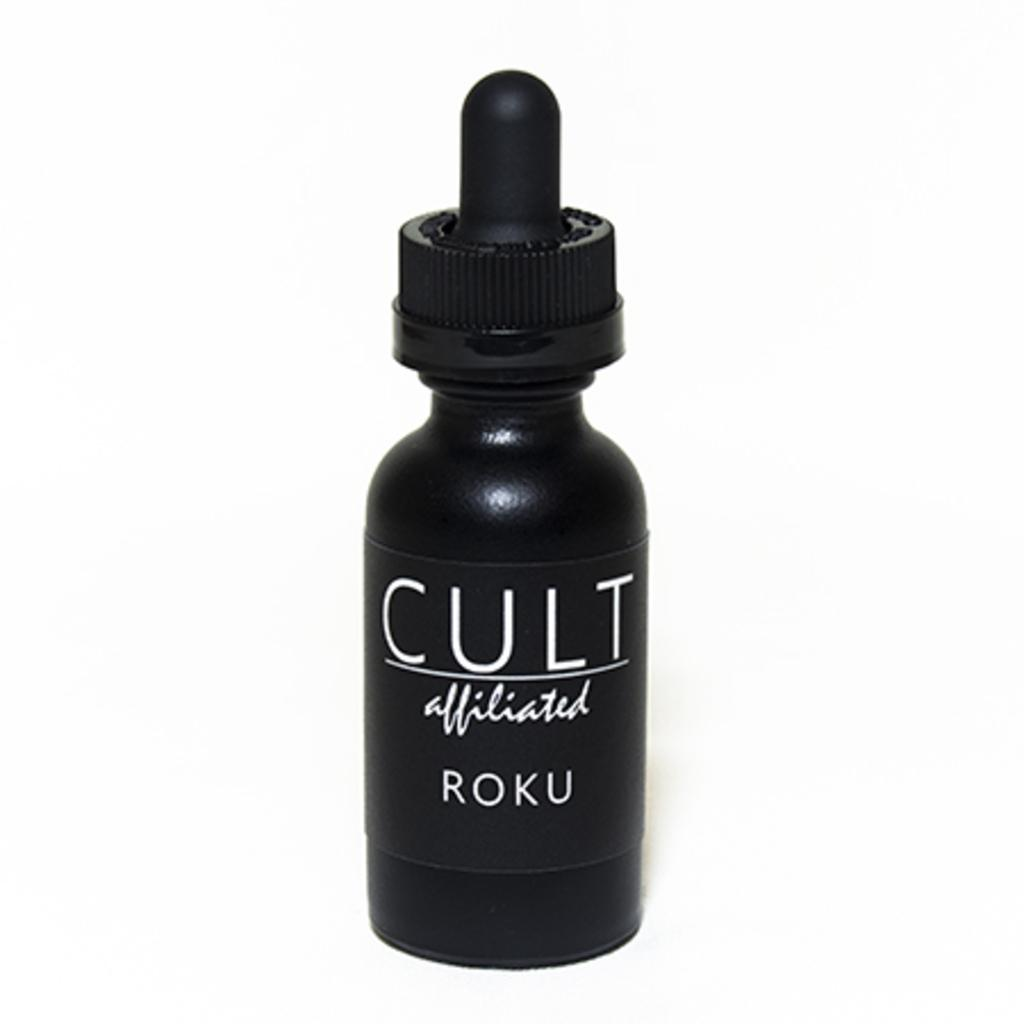<image>
Summarize the visual content of the image. A dropper bottle of Cult affiliated by Roku sits on a white table. 